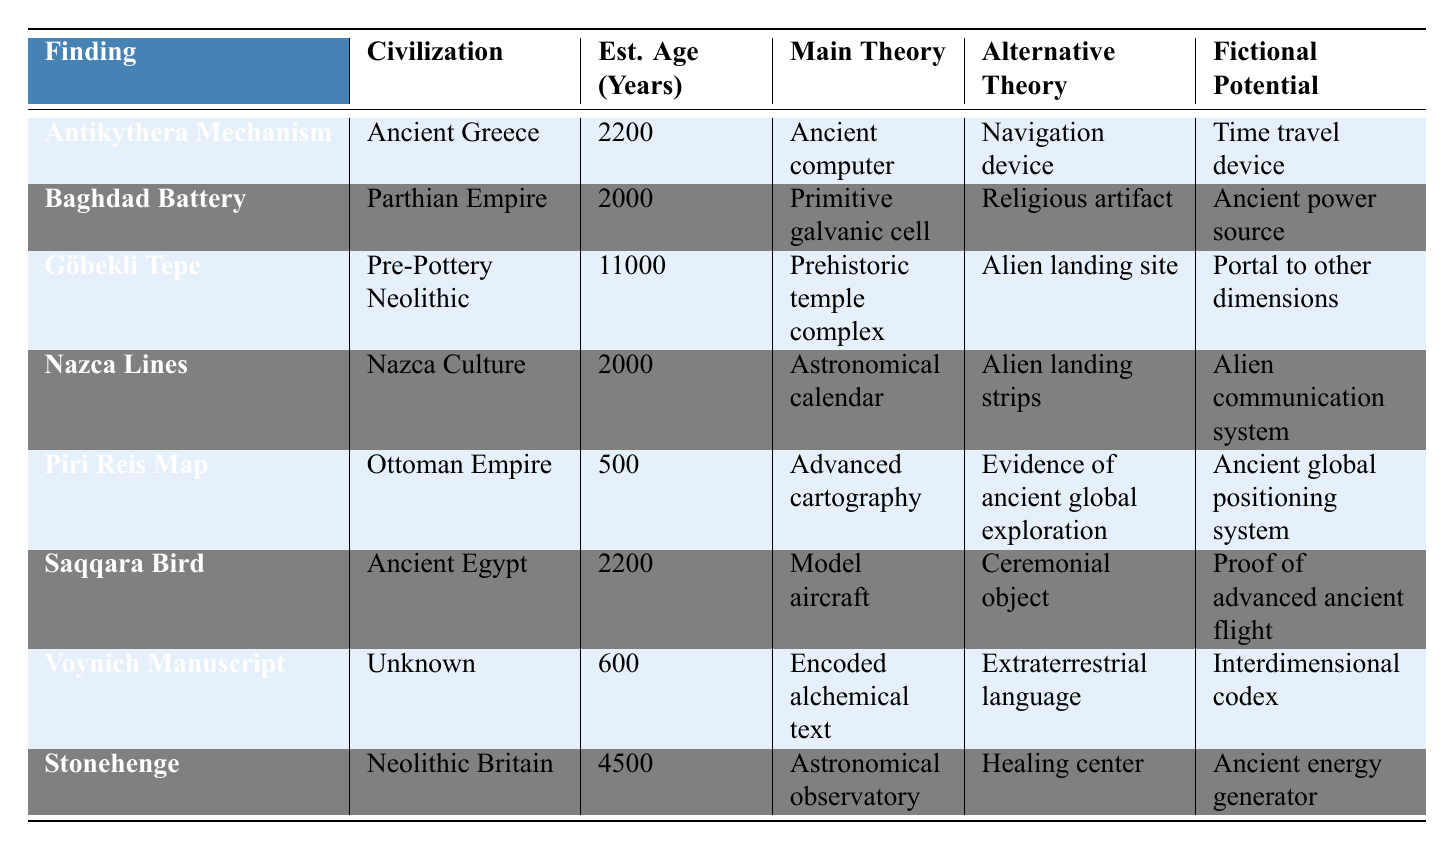What is the estimated age of the Göbekli Tepe? The estimated age of the Göbekli Tepe is provided directly in the table under the "Est. Age (Years)" column for that finding. It states 11000 years.
Answer: 11000 Which finding is associated with the Ancient Egypt civilization? Looking through the table, the finding listed under the "Civilization" column as Ancient Egypt is the "Saqqara Bird."
Answer: Saqqara Bird How many findings have an estimated age greater than 2000 years? First, we need to count the findings with estimated ages greater than 2000 years. The findings with ages above 2000 are: Antikythera Mechanism (2200), Göbekli Tepe (11000), and Stonehenge (4500), totaling 3 findings.
Answer: 3 Does the Piri Reis Map have an alternative theory related to global exploration? The table states that the alternative theory for the Piri Reis Map is "Evidence of ancient global exploration," which confirms that it is related.
Answer: Yes Which finding has the fictional potential described as "Interdimensional codex"? By examining the "Fictional Potential" column, the finding associated with "Interdimensional codex" is the "Voynich Manuscript."
Answer: Voynich Manuscript What is the average estimated age of all the findings listed? Adding the estimated ages: 2200 + 2000 + 11000 + 2000 + 500 + 2200 + 600 + 4500 = 22700. There are 8 findings, so the average age is 22700 / 8 = 2837.5.
Answer: 2837.5 Which finding's main theory suggests it was an astronomical observatory? The table indicates that the finding classified under the main theory stating it was an astronomical observatory is "Stonehenge."
Answer: Stonehenge Is the main theory of the Saqqara Bird related to ancient flight? The table identifies the main theory for the Saqqara Bird as "Model aircraft," which suggests a connection to ancient flight.
Answer: Yes What is the relationship between the Nazca Lines and alien theories? The alternative theory for the Nazca Lines is "Alien landing strips," indicating a relationship with alien theories.
Answer: Alien landing strips How many researchers are listed for findings that have unknown civilizations? The table shows that only the "Voynich Manuscript" has an unknown civilization and lists "Voynich" as its key researcher. Thus, there is only one researcher.
Answer: 1 